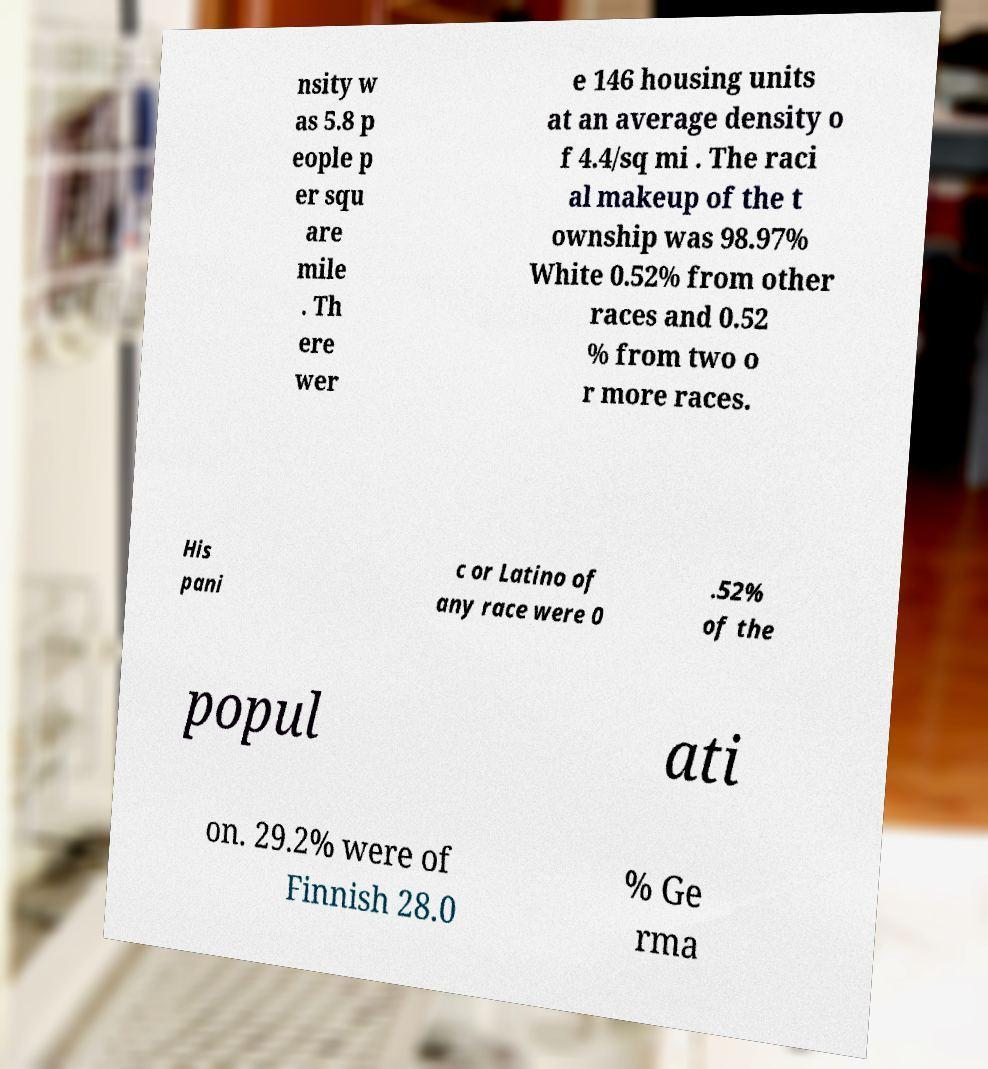What messages or text are displayed in this image? I need them in a readable, typed format. nsity w as 5.8 p eople p er squ are mile . Th ere wer e 146 housing units at an average density o f 4.4/sq mi . The raci al makeup of the t ownship was 98.97% White 0.52% from other races and 0.52 % from two o r more races. His pani c or Latino of any race were 0 .52% of the popul ati on. 29.2% were of Finnish 28.0 % Ge rma 